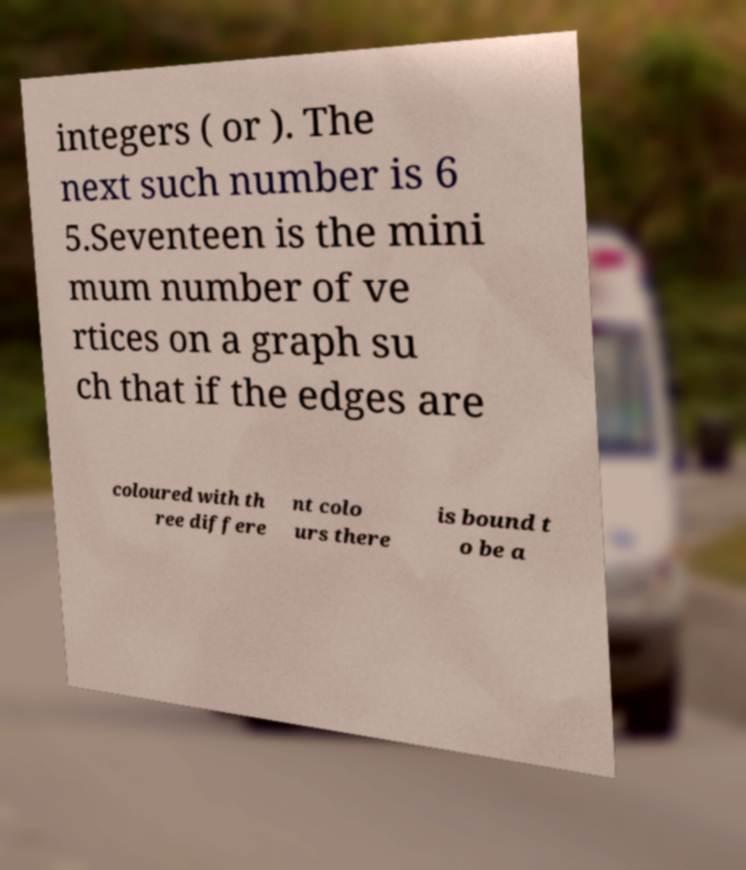For documentation purposes, I need the text within this image transcribed. Could you provide that? integers ( or ). The next such number is 6 5.Seventeen is the mini mum number of ve rtices on a graph su ch that if the edges are coloured with th ree differe nt colo urs there is bound t o be a 